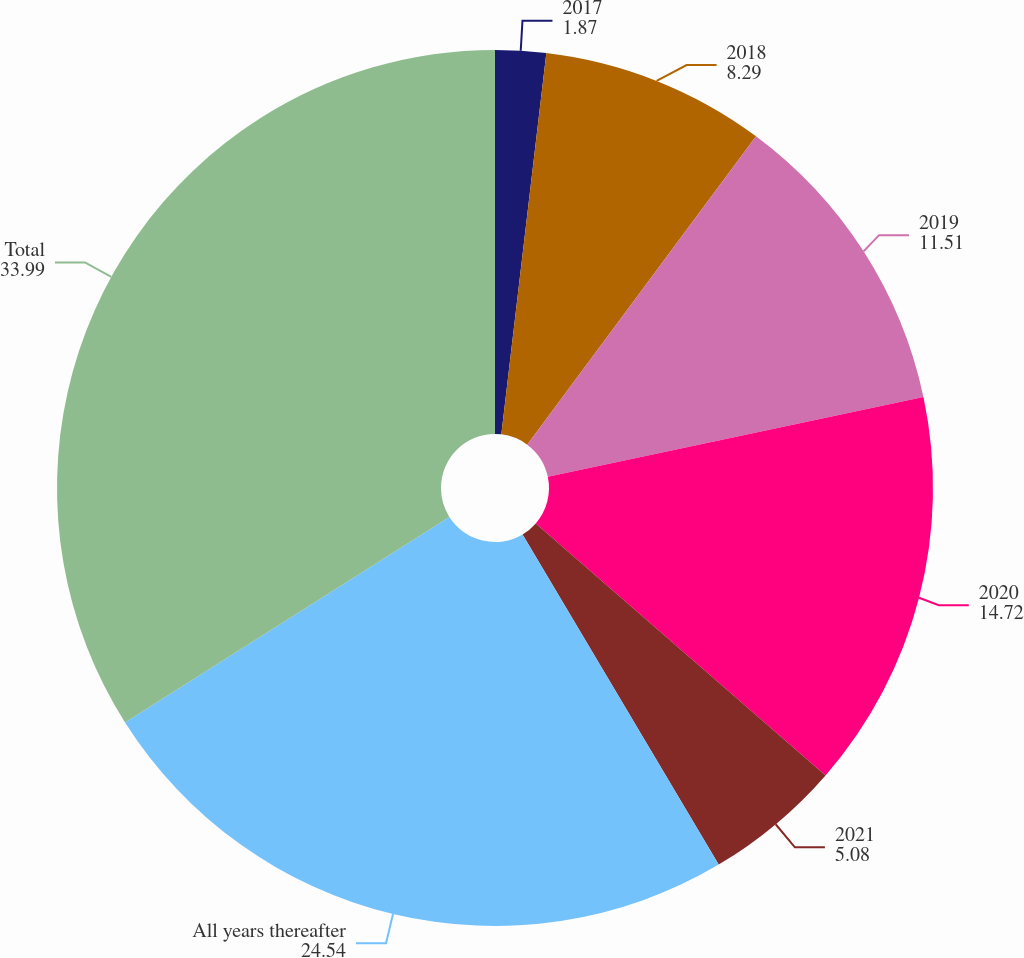Convert chart to OTSL. <chart><loc_0><loc_0><loc_500><loc_500><pie_chart><fcel>2017<fcel>2018<fcel>2019<fcel>2020<fcel>2021<fcel>All years thereafter<fcel>Total<nl><fcel>1.87%<fcel>8.29%<fcel>11.51%<fcel>14.72%<fcel>5.08%<fcel>24.54%<fcel>33.99%<nl></chart> 